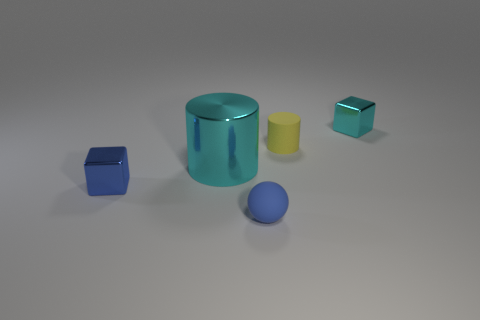Subtract all blue blocks. How many blocks are left? 1 Add 3 blocks. How many blocks are left? 5 Add 1 red rubber balls. How many red rubber balls exist? 1 Add 3 small blocks. How many objects exist? 8 Subtract 0 gray blocks. How many objects are left? 5 Subtract all cylinders. How many objects are left? 3 Subtract 1 cylinders. How many cylinders are left? 1 Subtract all blue cylinders. Subtract all brown blocks. How many cylinders are left? 2 Subtract all brown cubes. How many yellow cylinders are left? 1 Subtract all small cyan metallic spheres. Subtract all yellow rubber cylinders. How many objects are left? 4 